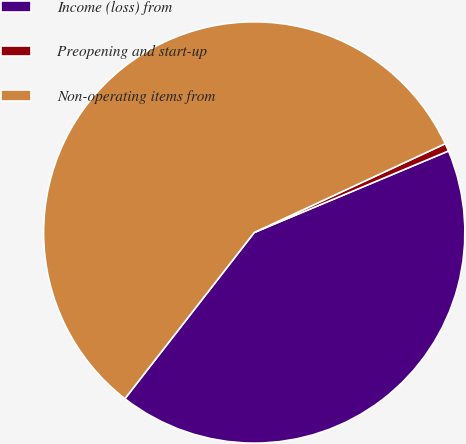<chart> <loc_0><loc_0><loc_500><loc_500><pie_chart><fcel>Income (loss) from<fcel>Preopening and start-up<fcel>Non-operating items from<nl><fcel>41.85%<fcel>0.6%<fcel>57.55%<nl></chart> 